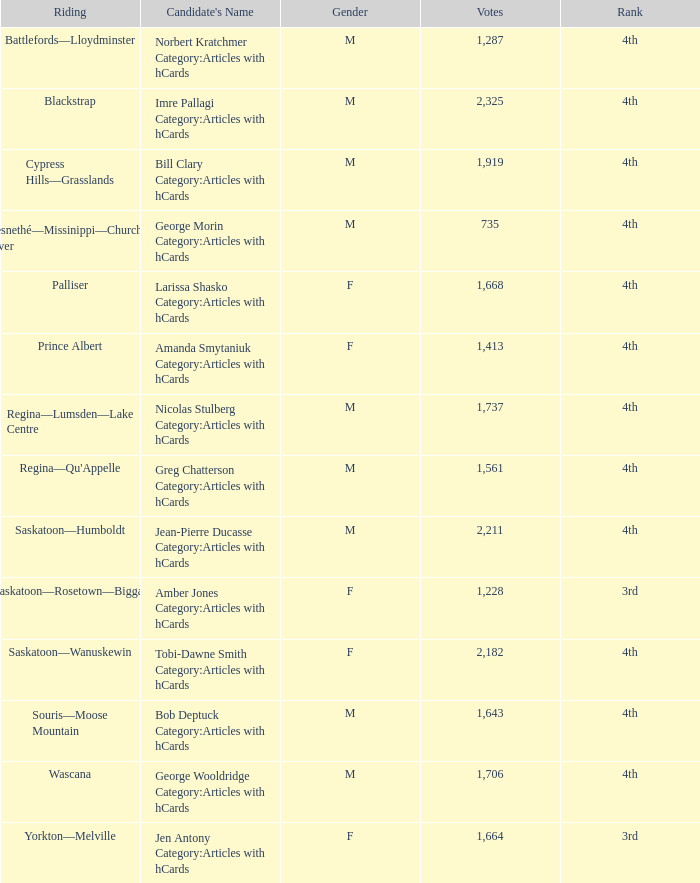What position does the candidate with over 2,211 votes hold? 4th. 